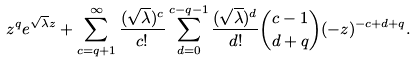Convert formula to latex. <formula><loc_0><loc_0><loc_500><loc_500>z ^ { q } e ^ { \sqrt { \lambda } z } + \sum _ { c = q + 1 } ^ { \infty } \frac { ( \sqrt { \lambda } ) ^ { c } } { c ! } \sum _ { d = 0 } ^ { c - q - 1 } \frac { ( \sqrt { \lambda } ) ^ { d } } { d ! } \binom { c - 1 } { d + q } ( - z ) ^ { - c + d + q } .</formula> 